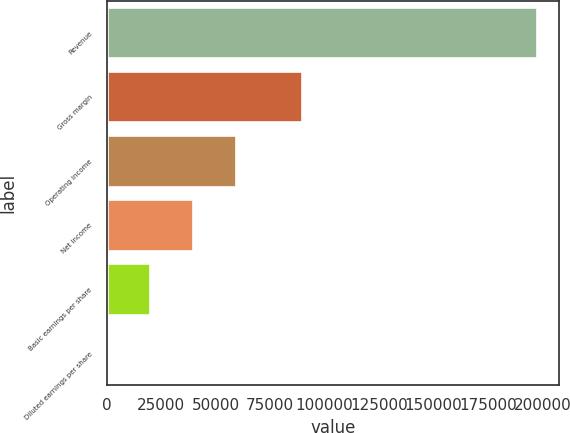Convert chart to OTSL. <chart><loc_0><loc_0><loc_500><loc_500><bar_chart><fcel>Revenue<fcel>Gross margin<fcel>Operating income<fcel>Net income<fcel>Basic earnings per share<fcel>Diluted earnings per share<nl><fcel>197659<fcel>89436<fcel>59297.8<fcel>39531.9<fcel>19766<fcel>0.09<nl></chart> 